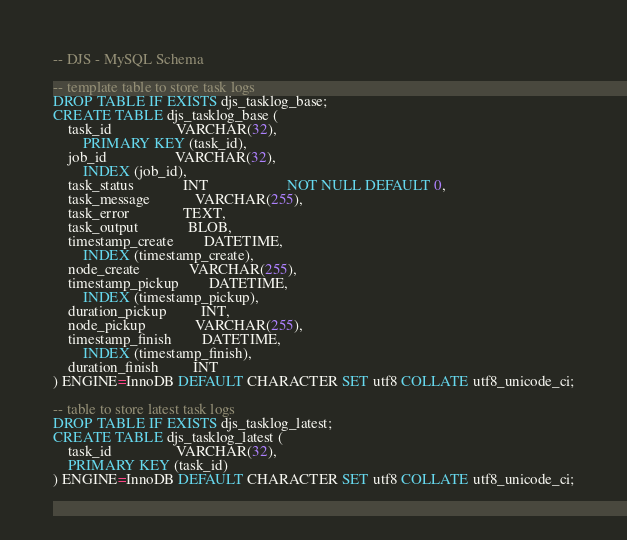Convert code to text. <code><loc_0><loc_0><loc_500><loc_500><_SQL_>-- DJS - MySQL Schema

-- template table to store task logs
DROP TABLE IF EXISTS djs_tasklog_base;
CREATE TABLE djs_tasklog_base (
    task_id                 VARCHAR(32),
        PRIMARY KEY (task_id),
    job_id                  VARCHAR(32),
        INDEX (job_id),
    task_status             INT                     NOT NULL DEFAULT 0,
    task_message            VARCHAR(255),
    task_error              TEXT,
    task_output             BLOB,
    timestamp_create        DATETIME,
        INDEX (timestamp_create),
    node_create             VARCHAR(255),
    timestamp_pickup        DATETIME,
        INDEX (timestamp_pickup),
    duration_pickup         INT,
    node_pickup             VARCHAR(255),
    timestamp_finish        DATETIME,
        INDEX (timestamp_finish),
    duration_finish         INT
) ENGINE=InnoDB DEFAULT CHARACTER SET utf8 COLLATE utf8_unicode_ci;

-- table to store latest task logs
DROP TABLE IF EXISTS djs_tasklog_latest;
CREATE TABLE djs_tasklog_latest (
    task_id                 VARCHAR(32),
    PRIMARY KEY (task_id)
) ENGINE=InnoDB DEFAULT CHARACTER SET utf8 COLLATE utf8_unicode_ci;
</code> 